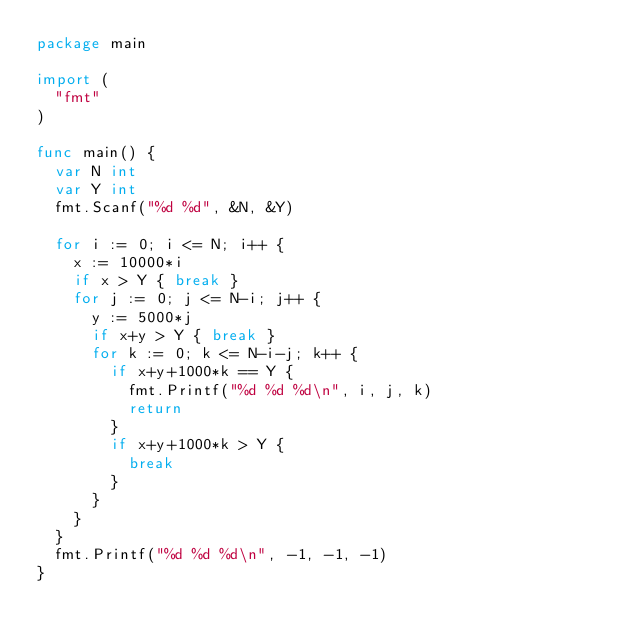<code> <loc_0><loc_0><loc_500><loc_500><_Go_>package main

import (
	"fmt"
)

func main() {
	var N int
	var Y int
	fmt.Scanf("%d %d", &N, &Y)

	for i := 0; i <= N; i++ {
		x := 10000*i
		if x > Y { break }
		for j := 0; j <= N-i; j++ {
			y := 5000*j
			if x+y > Y { break }
			for k := 0; k <= N-i-j; k++ {
				if x+y+1000*k == Y {
					fmt.Printf("%d %d %d\n", i, j, k)
					return
				}
				if x+y+1000*k > Y {
					break
				}
			}
		}
	}
	fmt.Printf("%d %d %d\n", -1, -1, -1)
}</code> 